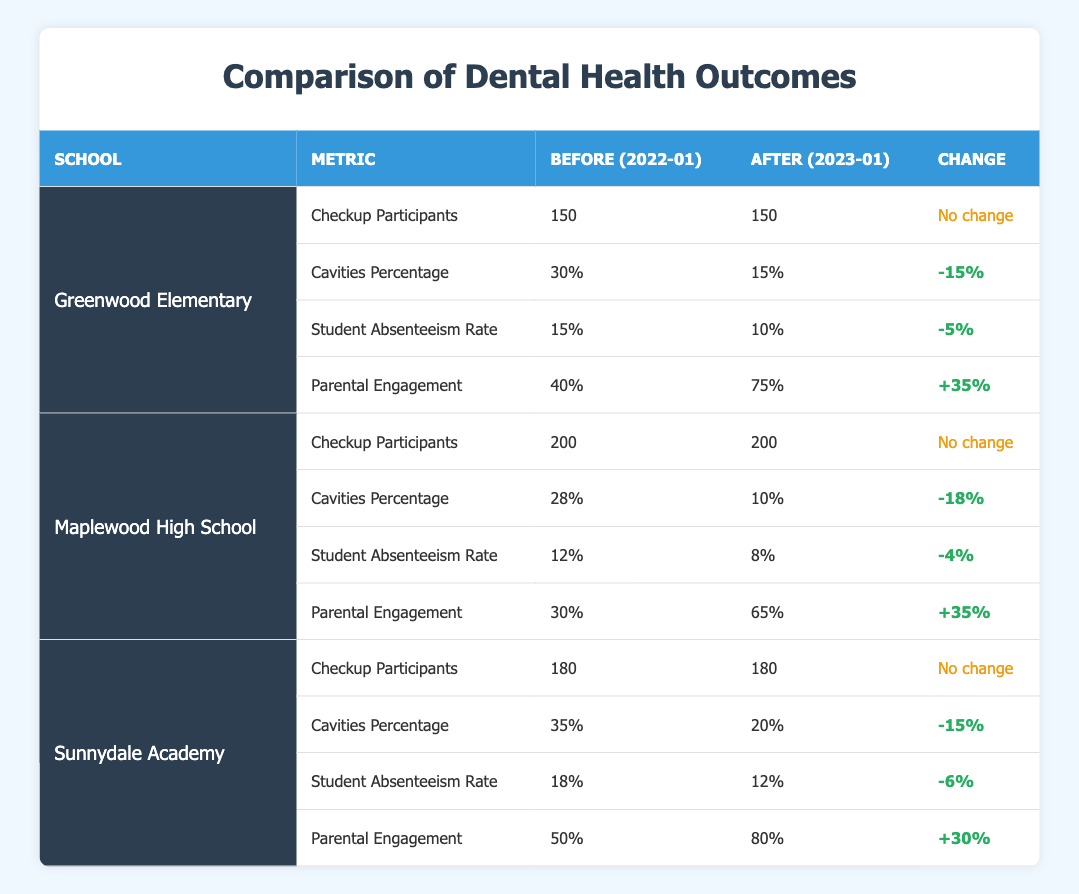What was the percentage of cavities at Greenwood Elementary before the initiatives? The table indicates that the cavities percentage at Greenwood Elementary before the initiatives was recorded at 30%.
Answer: 30% What change occurred in the student absenteeism rate at Maplewood High School? At Maplewood High School, the absenteeism rate decreased from 12% before the initiatives to 8% after, indicating a reduction of 4%.
Answer: -4% Did parental engagement improve for Sunnydale Academy after the initiatives? The data shows that parental engagement increased from 50% to 80% after the initiatives at Sunnydale Academy, which indicates improvement.
Answer: Yes Which school had the highest percentage of cavities after the initiatives? Reviewing the table, Sunnydale Academy had a cavities percentage of 20%, which was the highest when compared to Greenwood Elementary (15%) and Maplewood High School (10%).
Answer: Sunnydale Academy What is the overall average improvement in parental engagement across all three schools? The parental engagement percentages before the initiatives were 40%, 30%, and 50%, giving an average of (40 + 30 + 50) / 3 = 40%. After the initiatives, the percentages were 75%, 65%, and 80%, giving an average of (75 + 65 + 80) / 3 = 73.33%. The overall average improvement is 73.33% - 40% = 33.33%.
Answer: 33.33% 